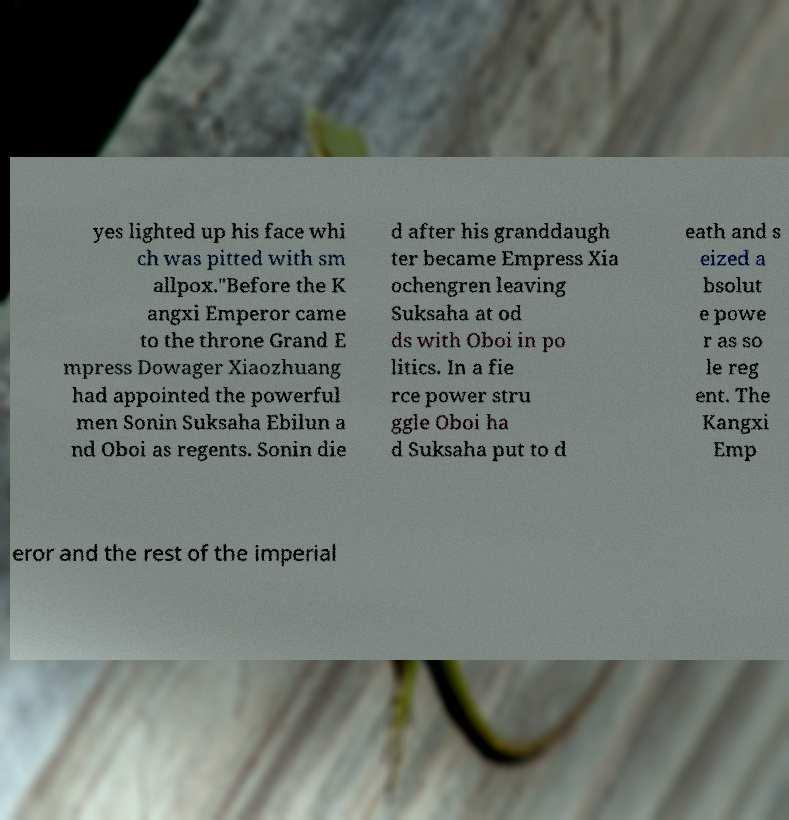Please identify and transcribe the text found in this image. yes lighted up his face whi ch was pitted with sm allpox."Before the K angxi Emperor came to the throne Grand E mpress Dowager Xiaozhuang had appointed the powerful men Sonin Suksaha Ebilun a nd Oboi as regents. Sonin die d after his granddaugh ter became Empress Xia ochengren leaving Suksaha at od ds with Oboi in po litics. In a fie rce power stru ggle Oboi ha d Suksaha put to d eath and s eized a bsolut e powe r as so le reg ent. The Kangxi Emp eror and the rest of the imperial 